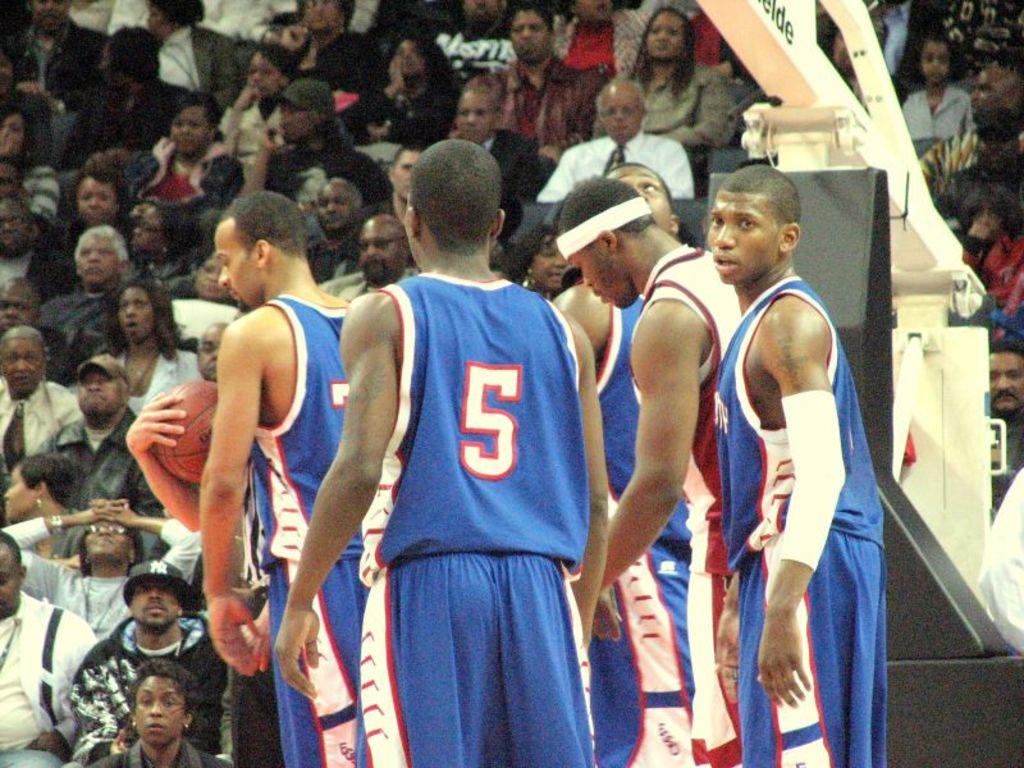<image>
Give a short and clear explanation of the subsequent image. A group of basketball players in blue jerseys, including number 5. 